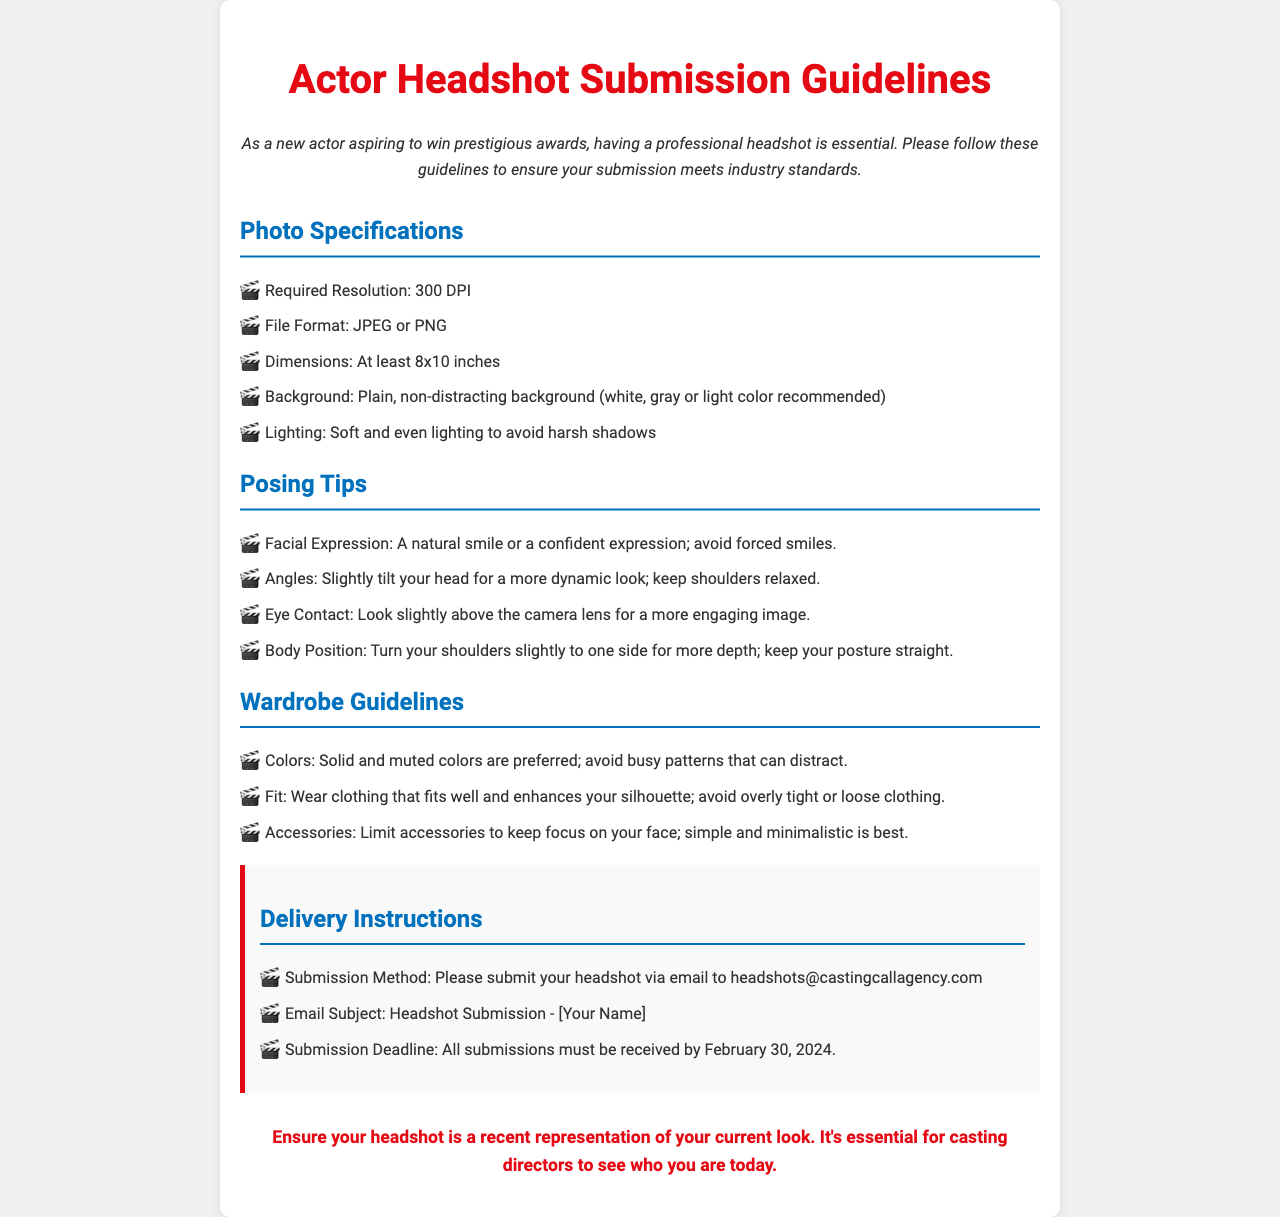What is the required resolution for the headshot? The required resolution is specified under Photo Specifications in the document.
Answer: 300 DPI What color backgrounds are recommended for the headshot? The document lists the preferred background colors in the Photo Specifications section.
Answer: White, gray or light color What is the minimum dimension for the headshot photo? The dimensions required are mentioned in the Photo Specifications section of the document.
Answer: At least 8x10 inches What file formats are acceptable for submission? The acceptable file formats are outlined in the Photo Specifications section.
Answer: JPEG or PNG What should be included in the email subject line for submission? The document details how to format the email subject in the Delivery Instructions section.
Answer: Headshot Submission - [Your Name] What lighting condition is recommended for headshot photos? The document highlights the ideal lighting in the Photo Specifications section.
Answer: Soft and even lighting How should actors position their shoulders for the photo? This information can be found in the Posing Tips section of the document.
Answer: Turn slightly to one side When is the submission deadline for the headshot? The deadline for submission is mentioned explicitly in the Delivery Instructions section.
Answer: February 30, 2024 What color clothing is preferred for the wardrobe? The preferred colors for clothing are listed in the Wardrobe Guidelines section.
Answer: Solid and muted colors 